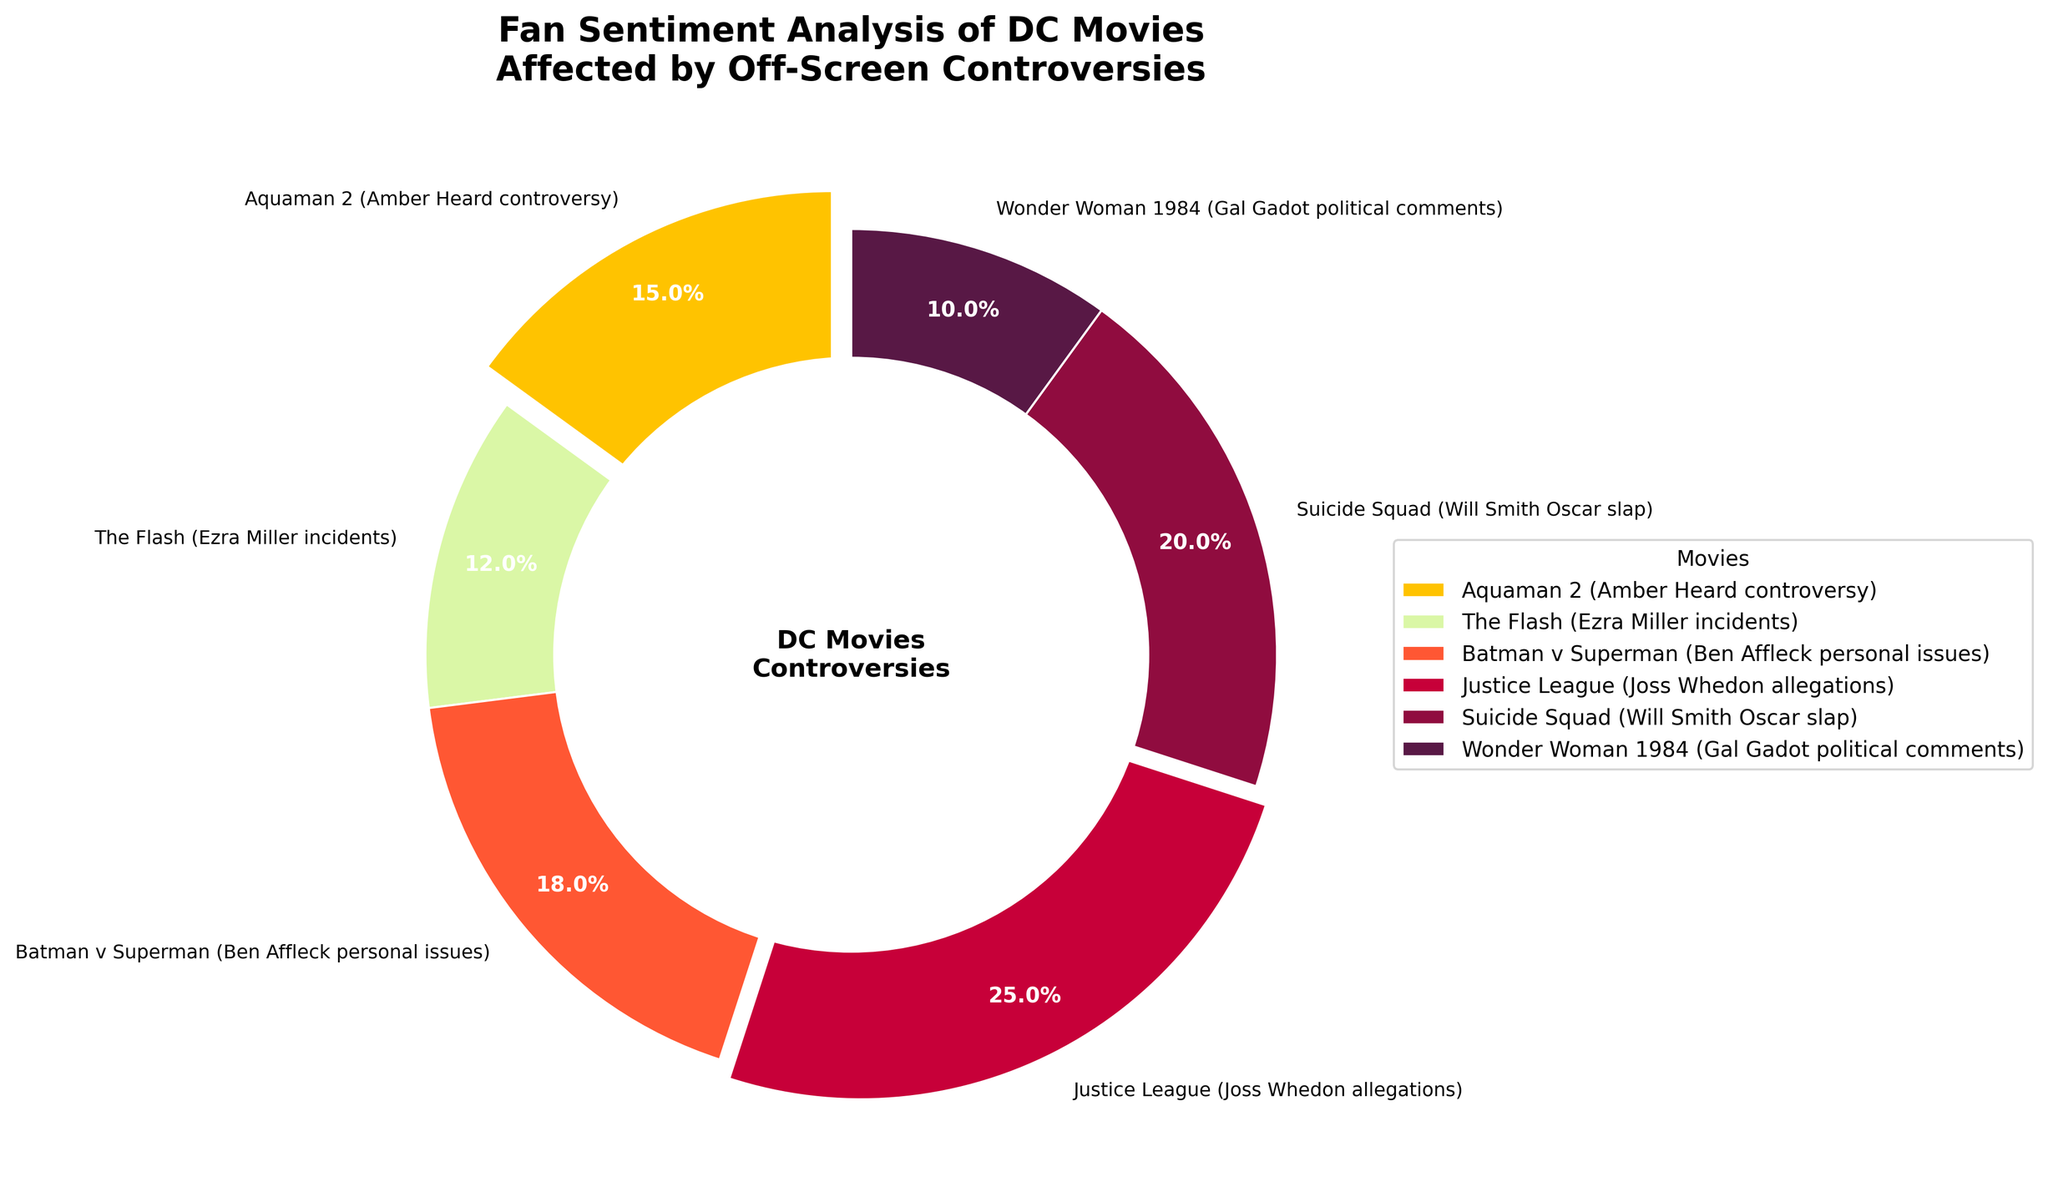Which movie has the highest percentage of sentiment based on the controversies? The figure shows that "Justice League (Joss Whedon allegations)" has the largest wedge, indicating the highest percentage of sentiment.
Answer: Justice League (Joss Whedon allegations) How much more sentiment does "Suicide Squad (Will Smith Oscar slap)" have compared to "Wonder Woman 1984 (Gal Gadot political comments)"? "Suicide Squad (Will Smith Oscar slap)" has 20%, while "Wonder Woman 1984 (Gal Gadot political comments)" has 10%. The difference is 20% - 10% = 10%.
Answer: 10% What is the combined sentiment percentage of "The Flash (Ezra Miller incidents)" and "Aquaman 2 (Amber Heard controversy)"? "The Flash (Ezra Miller incidents)" accounts for 12% and "Aquaman 2 (Amber Heard controversy)" accounts for 15%. Their combined sentiment is 12% + 15% = 27%.
Answer: 27% Are there more sentiments around "Batman v Superman (Ben Affleck personal issues)" or "Aquaman 2 (Amber Heard controversy)"? By looking at the wedges, "Batman v Superman (Ben Affleck personal issues)" has 18%, whereas "Aquaman 2 (Amber Heard controversy)" has 15%. Therefore, "Batman v Superman" has more sentiments.
Answer: Batman v Superman (Ben Affleck personal issues) What is the average sentiment percentage of all the DC movies listed? Add all sentiment percentages first: 15% (Aquaman 2) + 12% (The Flash) + 18% (Batman v Superman) + 25% (Justice League) + 20% (Suicide Squad) + 10% (Wonder Woman 1984) = 100%. Divide by the number of movies, which is 6: 100% / 6 = 16.67%.
Answer: 16.67% Which color represents "The Flash (Ezra Miller incidents)" in the pie chart? The color scheme used in the pie chart is an ordered series. Comparing the wedge color to the legend indicates that the color for "The Flash (Ezra Miller incidents)" is light green.
Answer: light green Among all movies, which one has the lowest sentiment percentage associated with its controversy? The pie chart shows that "Wonder Woman 1984 (Gal Gadot political comments)" has the smallest wedge, indicating the lowest sentiment percentage.
Answer: Wonder Woman 1984 (Gal Gadot political comments) By how much does the sentiment percentage of "Justice League (Joss Whedon allegations)" exceed the sentiment percentage of "The Flash (Ezra Miller incidents)"? "Justice League (Joss Whedon allegations)" has 25%, and "The Flash (Ezra Miller incidents)" has 12%. The difference is 25% - 12% = 13%.
Answer: 13% What is the percentage difference between "Batman v Superman (Ben Affleck personal issues)" and "Wonder Woman 1984 (Gal Gadot political comments)"? "Batman v Superman (Ben Affleck personal issues)" has 18% and "Wonder Woman 1984 (Gal Gadot political comments)" has 10%. The difference is 18% - 10% = 8%.
Answer: 8% 